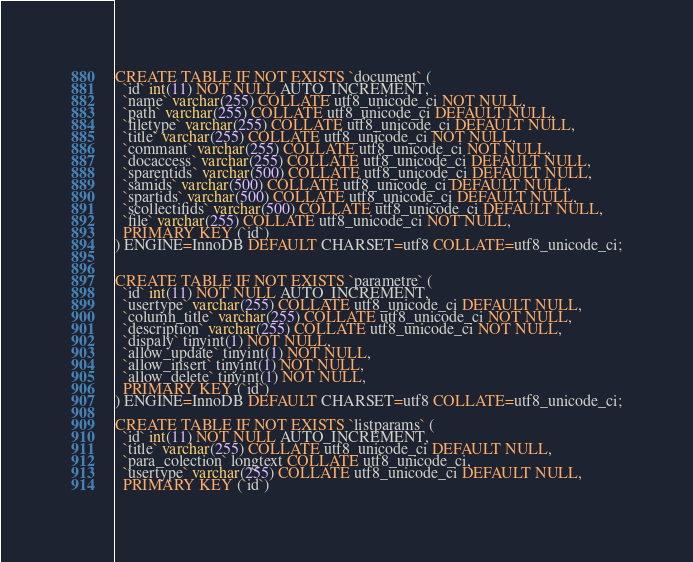<code> <loc_0><loc_0><loc_500><loc_500><_SQL_>CREATE TABLE IF NOT EXISTS `document` (
  `id` int(11) NOT NULL AUTO_INCREMENT,
  `name` varchar(255) COLLATE utf8_unicode_ci NOT NULL,
  `path` varchar(255) COLLATE utf8_unicode_ci DEFAULT NULL,
  `filetype` varchar(255) COLLATE utf8_unicode_ci DEFAULT NULL,
  `title` varchar(255) COLLATE utf8_unicode_ci NOT NULL,
  `commant` varchar(255) COLLATE utf8_unicode_ci NOT NULL,
  `docaccess` varchar(255) COLLATE utf8_unicode_ci DEFAULT NULL,
  `sparentids` varchar(500) COLLATE utf8_unicode_ci DEFAULT NULL,
  `samids` varchar(500) COLLATE utf8_unicode_ci DEFAULT NULL,
  `spartids` varchar(500) COLLATE utf8_unicode_ci DEFAULT NULL,
  `scollectifids` varchar(500) COLLATE utf8_unicode_ci DEFAULT NULL,
  `file` varchar(255) COLLATE utf8_unicode_ci NOT NULL,
  PRIMARY KEY (`id`)
) ENGINE=InnoDB DEFAULT CHARSET=utf8 COLLATE=utf8_unicode_ci;


CREATE TABLE IF NOT EXISTS `parametre` (
  `id` int(11) NOT NULL AUTO_INCREMENT,
  `usertype` varchar(255) COLLATE utf8_unicode_ci DEFAULT NULL,
  `column_title` varchar(255) COLLATE utf8_unicode_ci NOT NULL,
  `description` varchar(255) COLLATE utf8_unicode_ci NOT NULL,
  `dispaly` tinyint(1) NOT NULL,
  `allow_update` tinyint(1) NOT NULL,
  `allow_insert` tinyint(1) NOT NULL,
  `allow_delete` tinyint(1) NOT NULL,
  PRIMARY KEY (`id`)
) ENGINE=InnoDB DEFAULT CHARSET=utf8 COLLATE=utf8_unicode_ci;

CREATE TABLE IF NOT EXISTS `listparams` (
  `id` int(11) NOT NULL AUTO_INCREMENT,
  `title` varchar(255) COLLATE utf8_unicode_ci DEFAULT NULL,
  `para_colection` longtext COLLATE utf8_unicode_ci,
  `usertype` varchar(255) COLLATE utf8_unicode_ci DEFAULT NULL,
  PRIMARY KEY (`id`)</code> 